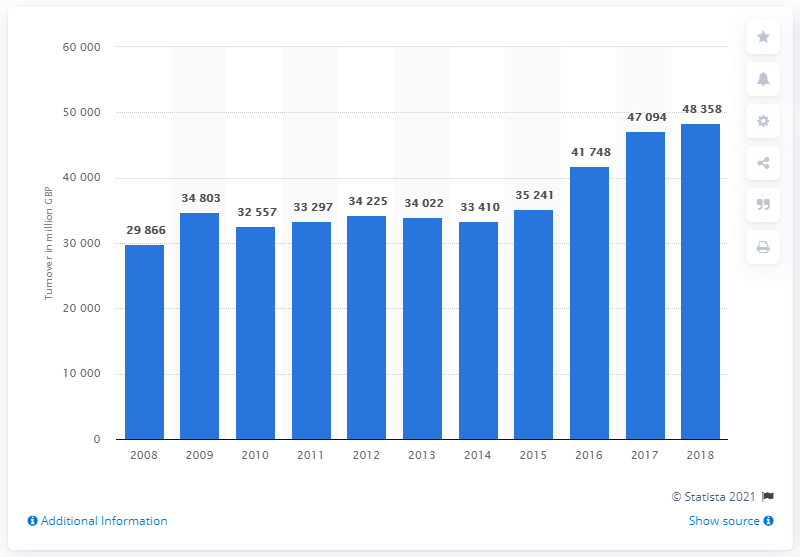Point out several critical features in this image. In 2018, the estimated turnover of pharmaceutical goods in the United Kingdom was approximately 48,358 million pounds. The annual turnover of pharmaceutical goods in the UK has significantly increased since 2014. 